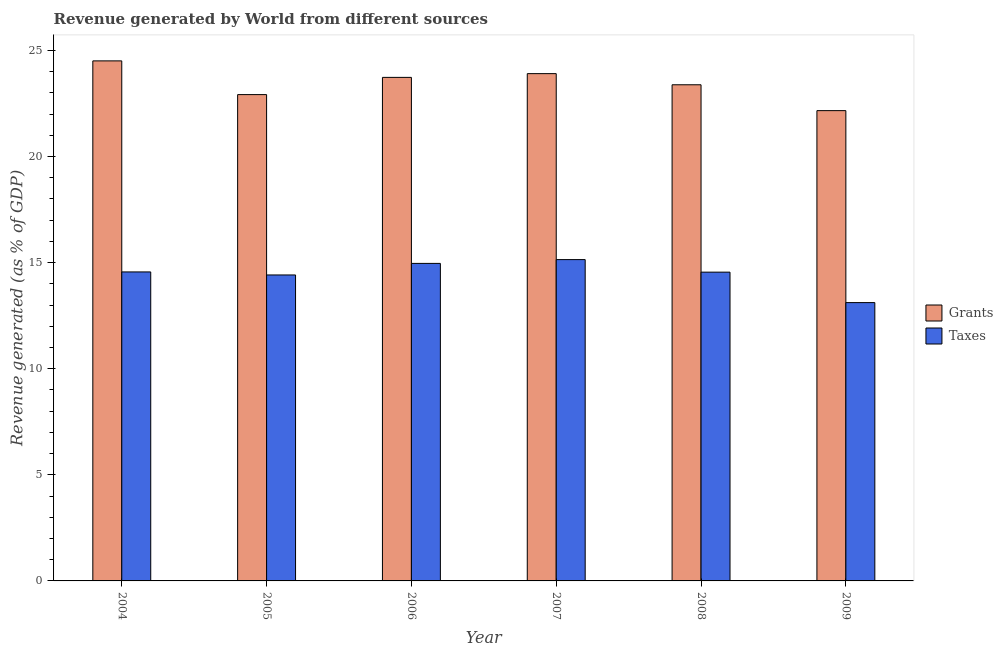How many different coloured bars are there?
Your answer should be compact. 2. How many groups of bars are there?
Your response must be concise. 6. Are the number of bars per tick equal to the number of legend labels?
Provide a short and direct response. Yes. Are the number of bars on each tick of the X-axis equal?
Make the answer very short. Yes. How many bars are there on the 5th tick from the left?
Your answer should be compact. 2. What is the revenue generated by taxes in 2006?
Offer a very short reply. 14.96. Across all years, what is the maximum revenue generated by grants?
Your answer should be very brief. 24.5. Across all years, what is the minimum revenue generated by grants?
Keep it short and to the point. 22.16. In which year was the revenue generated by grants maximum?
Your answer should be compact. 2004. In which year was the revenue generated by grants minimum?
Give a very brief answer. 2009. What is the total revenue generated by taxes in the graph?
Offer a very short reply. 86.74. What is the difference between the revenue generated by grants in 2004 and that in 2008?
Your response must be concise. 1.13. What is the difference between the revenue generated by taxes in 2008 and the revenue generated by grants in 2004?
Your response must be concise. -0.01. What is the average revenue generated by grants per year?
Give a very brief answer. 23.43. In the year 2009, what is the difference between the revenue generated by grants and revenue generated by taxes?
Ensure brevity in your answer.  0. In how many years, is the revenue generated by grants greater than 15 %?
Your answer should be very brief. 6. What is the ratio of the revenue generated by taxes in 2005 to that in 2007?
Provide a short and direct response. 0.95. Is the difference between the revenue generated by taxes in 2008 and 2009 greater than the difference between the revenue generated by grants in 2008 and 2009?
Provide a short and direct response. No. What is the difference between the highest and the second highest revenue generated by taxes?
Make the answer very short. 0.18. What is the difference between the highest and the lowest revenue generated by taxes?
Offer a very short reply. 2.03. In how many years, is the revenue generated by taxes greater than the average revenue generated by taxes taken over all years?
Provide a short and direct response. 4. Is the sum of the revenue generated by grants in 2007 and 2008 greater than the maximum revenue generated by taxes across all years?
Ensure brevity in your answer.  Yes. What does the 2nd bar from the left in 2006 represents?
Ensure brevity in your answer.  Taxes. What does the 1st bar from the right in 2005 represents?
Keep it short and to the point. Taxes. How many bars are there?
Ensure brevity in your answer.  12. How many years are there in the graph?
Give a very brief answer. 6. Are the values on the major ticks of Y-axis written in scientific E-notation?
Offer a very short reply. No. Does the graph contain grids?
Provide a short and direct response. No. How many legend labels are there?
Keep it short and to the point. 2. What is the title of the graph?
Your answer should be compact. Revenue generated by World from different sources. What is the label or title of the X-axis?
Provide a succinct answer. Year. What is the label or title of the Y-axis?
Provide a short and direct response. Revenue generated (as % of GDP). What is the Revenue generated (as % of GDP) in Grants in 2004?
Give a very brief answer. 24.5. What is the Revenue generated (as % of GDP) of Taxes in 2004?
Ensure brevity in your answer.  14.56. What is the Revenue generated (as % of GDP) of Grants in 2005?
Offer a terse response. 22.92. What is the Revenue generated (as % of GDP) in Taxes in 2005?
Make the answer very short. 14.42. What is the Revenue generated (as % of GDP) of Grants in 2006?
Provide a short and direct response. 23.73. What is the Revenue generated (as % of GDP) in Taxes in 2006?
Ensure brevity in your answer.  14.96. What is the Revenue generated (as % of GDP) of Grants in 2007?
Offer a very short reply. 23.9. What is the Revenue generated (as % of GDP) of Taxes in 2007?
Keep it short and to the point. 15.14. What is the Revenue generated (as % of GDP) of Grants in 2008?
Offer a terse response. 23.38. What is the Revenue generated (as % of GDP) in Taxes in 2008?
Offer a very short reply. 14.55. What is the Revenue generated (as % of GDP) of Grants in 2009?
Your answer should be compact. 22.16. What is the Revenue generated (as % of GDP) in Taxes in 2009?
Make the answer very short. 13.11. Across all years, what is the maximum Revenue generated (as % of GDP) of Grants?
Ensure brevity in your answer.  24.5. Across all years, what is the maximum Revenue generated (as % of GDP) of Taxes?
Ensure brevity in your answer.  15.14. Across all years, what is the minimum Revenue generated (as % of GDP) of Grants?
Give a very brief answer. 22.16. Across all years, what is the minimum Revenue generated (as % of GDP) of Taxes?
Your answer should be compact. 13.11. What is the total Revenue generated (as % of GDP) of Grants in the graph?
Your response must be concise. 140.59. What is the total Revenue generated (as % of GDP) of Taxes in the graph?
Your answer should be compact. 86.74. What is the difference between the Revenue generated (as % of GDP) of Grants in 2004 and that in 2005?
Offer a very short reply. 1.59. What is the difference between the Revenue generated (as % of GDP) of Taxes in 2004 and that in 2005?
Provide a short and direct response. 0.14. What is the difference between the Revenue generated (as % of GDP) of Grants in 2004 and that in 2006?
Ensure brevity in your answer.  0.78. What is the difference between the Revenue generated (as % of GDP) in Taxes in 2004 and that in 2006?
Ensure brevity in your answer.  -0.4. What is the difference between the Revenue generated (as % of GDP) in Grants in 2004 and that in 2007?
Your answer should be compact. 0.6. What is the difference between the Revenue generated (as % of GDP) of Taxes in 2004 and that in 2007?
Your response must be concise. -0.58. What is the difference between the Revenue generated (as % of GDP) in Grants in 2004 and that in 2008?
Keep it short and to the point. 1.13. What is the difference between the Revenue generated (as % of GDP) in Taxes in 2004 and that in 2008?
Ensure brevity in your answer.  0.01. What is the difference between the Revenue generated (as % of GDP) of Grants in 2004 and that in 2009?
Offer a very short reply. 2.34. What is the difference between the Revenue generated (as % of GDP) of Taxes in 2004 and that in 2009?
Your answer should be compact. 1.45. What is the difference between the Revenue generated (as % of GDP) in Grants in 2005 and that in 2006?
Provide a short and direct response. -0.81. What is the difference between the Revenue generated (as % of GDP) of Taxes in 2005 and that in 2006?
Offer a terse response. -0.54. What is the difference between the Revenue generated (as % of GDP) in Grants in 2005 and that in 2007?
Ensure brevity in your answer.  -0.99. What is the difference between the Revenue generated (as % of GDP) in Taxes in 2005 and that in 2007?
Your answer should be very brief. -0.72. What is the difference between the Revenue generated (as % of GDP) in Grants in 2005 and that in 2008?
Keep it short and to the point. -0.46. What is the difference between the Revenue generated (as % of GDP) of Taxes in 2005 and that in 2008?
Your answer should be compact. -0.13. What is the difference between the Revenue generated (as % of GDP) in Grants in 2005 and that in 2009?
Your answer should be very brief. 0.76. What is the difference between the Revenue generated (as % of GDP) of Taxes in 2005 and that in 2009?
Make the answer very short. 1.3. What is the difference between the Revenue generated (as % of GDP) of Grants in 2006 and that in 2007?
Keep it short and to the point. -0.18. What is the difference between the Revenue generated (as % of GDP) in Taxes in 2006 and that in 2007?
Provide a succinct answer. -0.18. What is the difference between the Revenue generated (as % of GDP) of Grants in 2006 and that in 2008?
Offer a very short reply. 0.35. What is the difference between the Revenue generated (as % of GDP) in Taxes in 2006 and that in 2008?
Your answer should be very brief. 0.41. What is the difference between the Revenue generated (as % of GDP) of Grants in 2006 and that in 2009?
Your answer should be very brief. 1.57. What is the difference between the Revenue generated (as % of GDP) of Taxes in 2006 and that in 2009?
Provide a succinct answer. 1.85. What is the difference between the Revenue generated (as % of GDP) of Grants in 2007 and that in 2008?
Offer a terse response. 0.52. What is the difference between the Revenue generated (as % of GDP) in Taxes in 2007 and that in 2008?
Make the answer very short. 0.59. What is the difference between the Revenue generated (as % of GDP) in Grants in 2007 and that in 2009?
Ensure brevity in your answer.  1.74. What is the difference between the Revenue generated (as % of GDP) of Taxes in 2007 and that in 2009?
Ensure brevity in your answer.  2.03. What is the difference between the Revenue generated (as % of GDP) in Grants in 2008 and that in 2009?
Your answer should be very brief. 1.22. What is the difference between the Revenue generated (as % of GDP) in Taxes in 2008 and that in 2009?
Keep it short and to the point. 1.44. What is the difference between the Revenue generated (as % of GDP) of Grants in 2004 and the Revenue generated (as % of GDP) of Taxes in 2005?
Provide a short and direct response. 10.09. What is the difference between the Revenue generated (as % of GDP) of Grants in 2004 and the Revenue generated (as % of GDP) of Taxes in 2006?
Provide a succinct answer. 9.54. What is the difference between the Revenue generated (as % of GDP) in Grants in 2004 and the Revenue generated (as % of GDP) in Taxes in 2007?
Your answer should be very brief. 9.36. What is the difference between the Revenue generated (as % of GDP) of Grants in 2004 and the Revenue generated (as % of GDP) of Taxes in 2008?
Offer a very short reply. 9.95. What is the difference between the Revenue generated (as % of GDP) of Grants in 2004 and the Revenue generated (as % of GDP) of Taxes in 2009?
Offer a very short reply. 11.39. What is the difference between the Revenue generated (as % of GDP) of Grants in 2005 and the Revenue generated (as % of GDP) of Taxes in 2006?
Give a very brief answer. 7.95. What is the difference between the Revenue generated (as % of GDP) in Grants in 2005 and the Revenue generated (as % of GDP) in Taxes in 2007?
Your answer should be very brief. 7.77. What is the difference between the Revenue generated (as % of GDP) of Grants in 2005 and the Revenue generated (as % of GDP) of Taxes in 2008?
Keep it short and to the point. 8.37. What is the difference between the Revenue generated (as % of GDP) of Grants in 2005 and the Revenue generated (as % of GDP) of Taxes in 2009?
Keep it short and to the point. 9.8. What is the difference between the Revenue generated (as % of GDP) of Grants in 2006 and the Revenue generated (as % of GDP) of Taxes in 2007?
Keep it short and to the point. 8.59. What is the difference between the Revenue generated (as % of GDP) in Grants in 2006 and the Revenue generated (as % of GDP) in Taxes in 2008?
Provide a short and direct response. 9.18. What is the difference between the Revenue generated (as % of GDP) of Grants in 2006 and the Revenue generated (as % of GDP) of Taxes in 2009?
Ensure brevity in your answer.  10.61. What is the difference between the Revenue generated (as % of GDP) in Grants in 2007 and the Revenue generated (as % of GDP) in Taxes in 2008?
Provide a succinct answer. 9.35. What is the difference between the Revenue generated (as % of GDP) in Grants in 2007 and the Revenue generated (as % of GDP) in Taxes in 2009?
Offer a very short reply. 10.79. What is the difference between the Revenue generated (as % of GDP) in Grants in 2008 and the Revenue generated (as % of GDP) in Taxes in 2009?
Give a very brief answer. 10.26. What is the average Revenue generated (as % of GDP) of Grants per year?
Offer a terse response. 23.43. What is the average Revenue generated (as % of GDP) of Taxes per year?
Provide a short and direct response. 14.46. In the year 2004, what is the difference between the Revenue generated (as % of GDP) of Grants and Revenue generated (as % of GDP) of Taxes?
Your answer should be compact. 9.94. In the year 2005, what is the difference between the Revenue generated (as % of GDP) of Grants and Revenue generated (as % of GDP) of Taxes?
Ensure brevity in your answer.  8.5. In the year 2006, what is the difference between the Revenue generated (as % of GDP) in Grants and Revenue generated (as % of GDP) in Taxes?
Provide a short and direct response. 8.77. In the year 2007, what is the difference between the Revenue generated (as % of GDP) in Grants and Revenue generated (as % of GDP) in Taxes?
Provide a short and direct response. 8.76. In the year 2008, what is the difference between the Revenue generated (as % of GDP) of Grants and Revenue generated (as % of GDP) of Taxes?
Offer a terse response. 8.83. In the year 2009, what is the difference between the Revenue generated (as % of GDP) in Grants and Revenue generated (as % of GDP) in Taxes?
Provide a short and direct response. 9.05. What is the ratio of the Revenue generated (as % of GDP) of Grants in 2004 to that in 2005?
Give a very brief answer. 1.07. What is the ratio of the Revenue generated (as % of GDP) in Taxes in 2004 to that in 2005?
Your answer should be compact. 1.01. What is the ratio of the Revenue generated (as % of GDP) of Grants in 2004 to that in 2006?
Your answer should be very brief. 1.03. What is the ratio of the Revenue generated (as % of GDP) in Taxes in 2004 to that in 2006?
Your answer should be very brief. 0.97. What is the ratio of the Revenue generated (as % of GDP) in Grants in 2004 to that in 2007?
Your answer should be compact. 1.03. What is the ratio of the Revenue generated (as % of GDP) of Taxes in 2004 to that in 2007?
Ensure brevity in your answer.  0.96. What is the ratio of the Revenue generated (as % of GDP) of Grants in 2004 to that in 2008?
Offer a very short reply. 1.05. What is the ratio of the Revenue generated (as % of GDP) of Taxes in 2004 to that in 2008?
Offer a very short reply. 1. What is the ratio of the Revenue generated (as % of GDP) in Grants in 2004 to that in 2009?
Keep it short and to the point. 1.11. What is the ratio of the Revenue generated (as % of GDP) in Taxes in 2004 to that in 2009?
Keep it short and to the point. 1.11. What is the ratio of the Revenue generated (as % of GDP) of Grants in 2005 to that in 2006?
Make the answer very short. 0.97. What is the ratio of the Revenue generated (as % of GDP) in Taxes in 2005 to that in 2006?
Offer a terse response. 0.96. What is the ratio of the Revenue generated (as % of GDP) in Grants in 2005 to that in 2007?
Provide a short and direct response. 0.96. What is the ratio of the Revenue generated (as % of GDP) in Taxes in 2005 to that in 2007?
Offer a very short reply. 0.95. What is the ratio of the Revenue generated (as % of GDP) in Grants in 2005 to that in 2008?
Offer a very short reply. 0.98. What is the ratio of the Revenue generated (as % of GDP) in Taxes in 2005 to that in 2008?
Offer a terse response. 0.99. What is the ratio of the Revenue generated (as % of GDP) in Grants in 2005 to that in 2009?
Your answer should be compact. 1.03. What is the ratio of the Revenue generated (as % of GDP) in Taxes in 2005 to that in 2009?
Keep it short and to the point. 1.1. What is the ratio of the Revenue generated (as % of GDP) in Grants in 2006 to that in 2007?
Your answer should be compact. 0.99. What is the ratio of the Revenue generated (as % of GDP) in Taxes in 2006 to that in 2007?
Give a very brief answer. 0.99. What is the ratio of the Revenue generated (as % of GDP) in Grants in 2006 to that in 2008?
Make the answer very short. 1.01. What is the ratio of the Revenue generated (as % of GDP) of Taxes in 2006 to that in 2008?
Your answer should be compact. 1.03. What is the ratio of the Revenue generated (as % of GDP) in Grants in 2006 to that in 2009?
Your answer should be compact. 1.07. What is the ratio of the Revenue generated (as % of GDP) of Taxes in 2006 to that in 2009?
Provide a succinct answer. 1.14. What is the ratio of the Revenue generated (as % of GDP) of Grants in 2007 to that in 2008?
Provide a succinct answer. 1.02. What is the ratio of the Revenue generated (as % of GDP) in Taxes in 2007 to that in 2008?
Make the answer very short. 1.04. What is the ratio of the Revenue generated (as % of GDP) of Grants in 2007 to that in 2009?
Provide a short and direct response. 1.08. What is the ratio of the Revenue generated (as % of GDP) of Taxes in 2007 to that in 2009?
Your answer should be very brief. 1.15. What is the ratio of the Revenue generated (as % of GDP) of Grants in 2008 to that in 2009?
Your response must be concise. 1.05. What is the ratio of the Revenue generated (as % of GDP) in Taxes in 2008 to that in 2009?
Your response must be concise. 1.11. What is the difference between the highest and the second highest Revenue generated (as % of GDP) in Grants?
Your answer should be compact. 0.6. What is the difference between the highest and the second highest Revenue generated (as % of GDP) in Taxes?
Ensure brevity in your answer.  0.18. What is the difference between the highest and the lowest Revenue generated (as % of GDP) of Grants?
Make the answer very short. 2.34. What is the difference between the highest and the lowest Revenue generated (as % of GDP) of Taxes?
Offer a terse response. 2.03. 